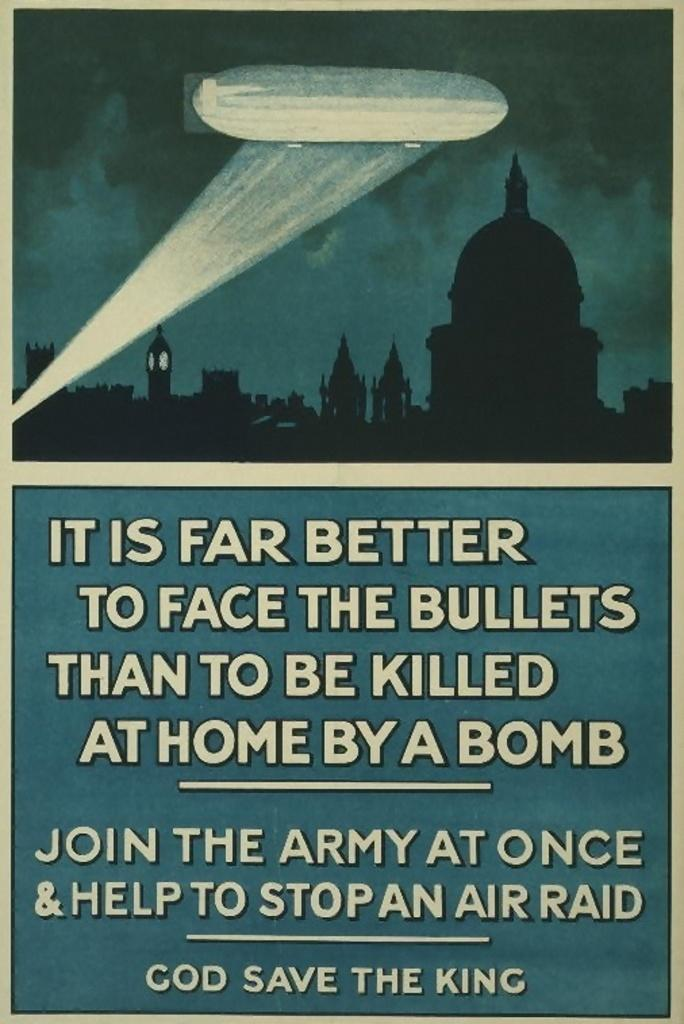Provide a one-sentence caption for the provided image. A vintage advertisement to join the army states that it's better "to face the bullets". 